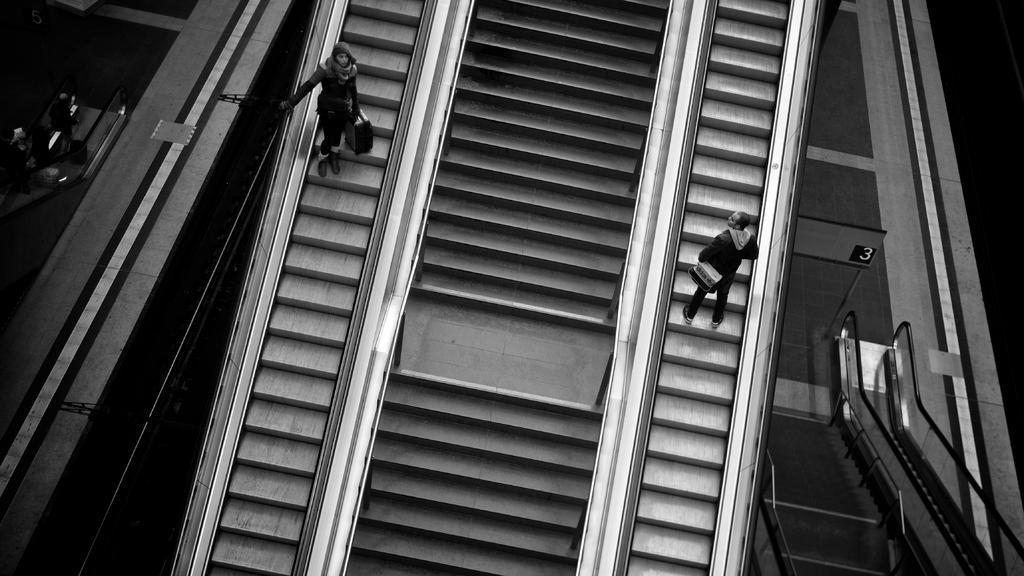Could you give a brief overview of what you see in this image? There is a stair case and there are two persons standing on an escalator on either sides of it. 